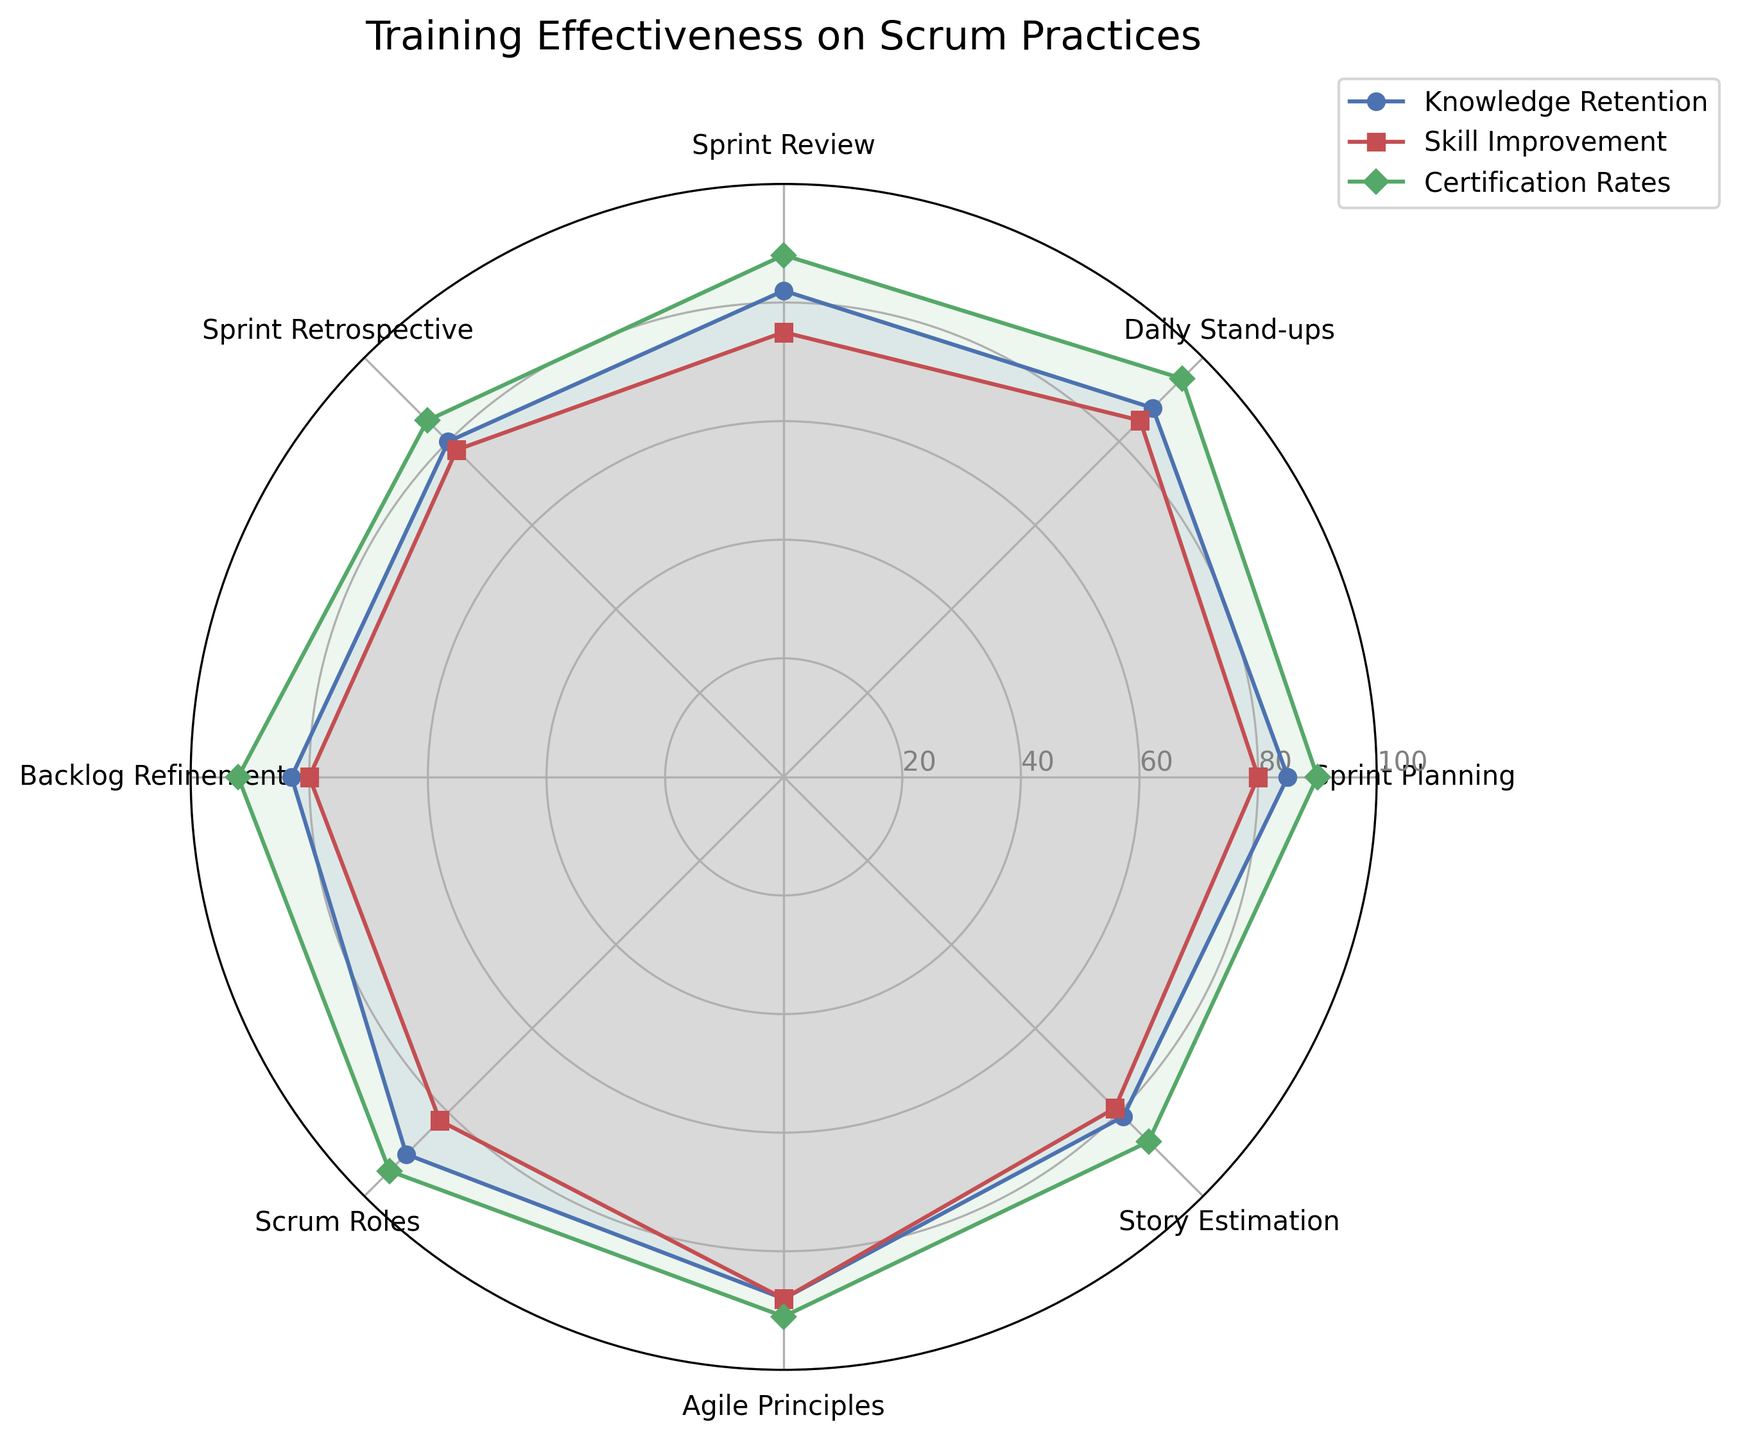Which category has the highest knowledge retention? By looking at the data points on the radar chart, identify the category that has the highest value in the Knowledge Retention line (blue).
Answer: Scrum Roles Which category shows the greatest difference between knowledge retention and skill improvement? For each category, subtract the Skill Improvement value from the Knowledge Retention value, and find the category with the maximum result. Differences are: Sprint Planning (5), Daily Stand-ups (3), Sprint Review (7), Sprint Retrospective (2), Backlog Refinement (3), Scrum Roles (8), Agile Principles (0), and Story Estimation (2). The greatest difference is 8 for Scrum Roles.
Answer: Scrum Roles Which metric is consistently the highest across most categories? Look at the relative heights of the lines across all categories. The green line (Certification Rates) is generally highest for the majority of categories.
Answer: Certification Rates What is the average skill improvement rate across all categories? Sum the Skill Improvement rates and then divide by the number of categories: (80 + 85 + 75 + 78 + 80 + 82 + 88 + 79) / 8 = 647 / 8 = 80.875.
Answer: 80.875 Compare the highest certification rate with the highest skill improvement rate. Which one is greater? The highest certification rate is 95 (Daily Stand-ups), and the highest skill improvement rate is 88 (Agile Principles). 95 is greater than 88.
Answer: Certification Rates is greater Which category shows the most balanced performance across all three metrics? Determine the category where the values for Knowledge Retention, Skill Improvement, and Certification Rates are closest in value. Agile Principles (88, 88, 91) and Scrum Roles (90, 82, 94) are close, but Agile Principles is slightly more balanced.
Answer: Agile Principles Which metric has the lowest value and in which category? Identify the lowest data point in the radar chart or data table. The lowest value is 75 in Skill Improvement for Sprint Review.
Answer: Skill Improvement in Sprint Review 